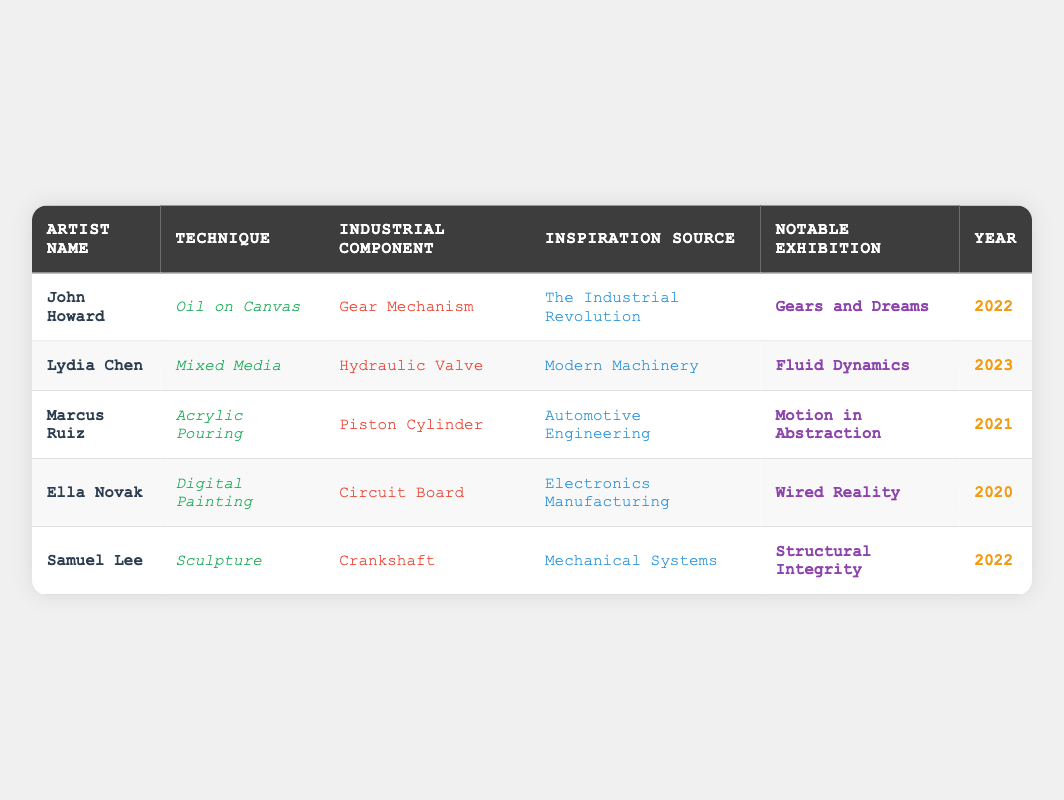What technique did John Howard use in his artwork? According to the table, John Howard's technique is "Oil on Canvas." This information can be directly found in the row corresponding to John Howard.
Answer: Oil on Canvas Which artist had a notable exhibition in 2023? The table indicates that Lydia Chen had a notable exhibition in 2023, as seen in her row where the year 2023 is listed under the "Year" column.
Answer: Lydia Chen Is there an artist who used "Sculpture" as a technique? Yes, Samuel Lee is the artist who used "Sculpture" as his technique according to his entry in the table. Therefore, the answer is true.
Answer: Yes What industrial component did Marcus Ruiz depict? The table shows that Marcus Ruiz depicted the "Piston Cylinder" in his artwork, which can be found in the "Industrial Component" column of his row.
Answer: Piston Cylinder How many different techniques are represented in the table? There are five distinct techniques listed in the table: Oil on Canvas, Mixed Media, Acrylic Pouring, Digital Painting, and Sculpture. Hence, counting them gives a total of five techniques.
Answer: 5 Which artist's inspiration source relates to "Electronics Manufacturing"? The table indicates that Ella Novak's inspiration source is "Electronics Manufacturing." This information is located in her row under the "Inspiration Source" column.
Answer: Ella Novak What is the earliest year of exhibition mentioned in the table? By reviewing the "Year" column of all entries, the earliest year is 2020, which corresponds to Ella Novak's exhibition.
Answer: 2020 Which artist used a technique that involves mixing various materials? Lydia Chen used a technique called "Mixed Media," as indicated in her row under the "Technique" column.
Answer: Lydia Chen What is the common theme of inspiration for all artists listed? The inspiration sources for each artist center on different aspects of machinery and engineering, including the Industrial Revolution, Modern Machinery, Automotive Engineering, Electronics Manufacturing, and Mechanical Systems. This common theme relates to industrial components.
Answer: Industrial components and machinery 